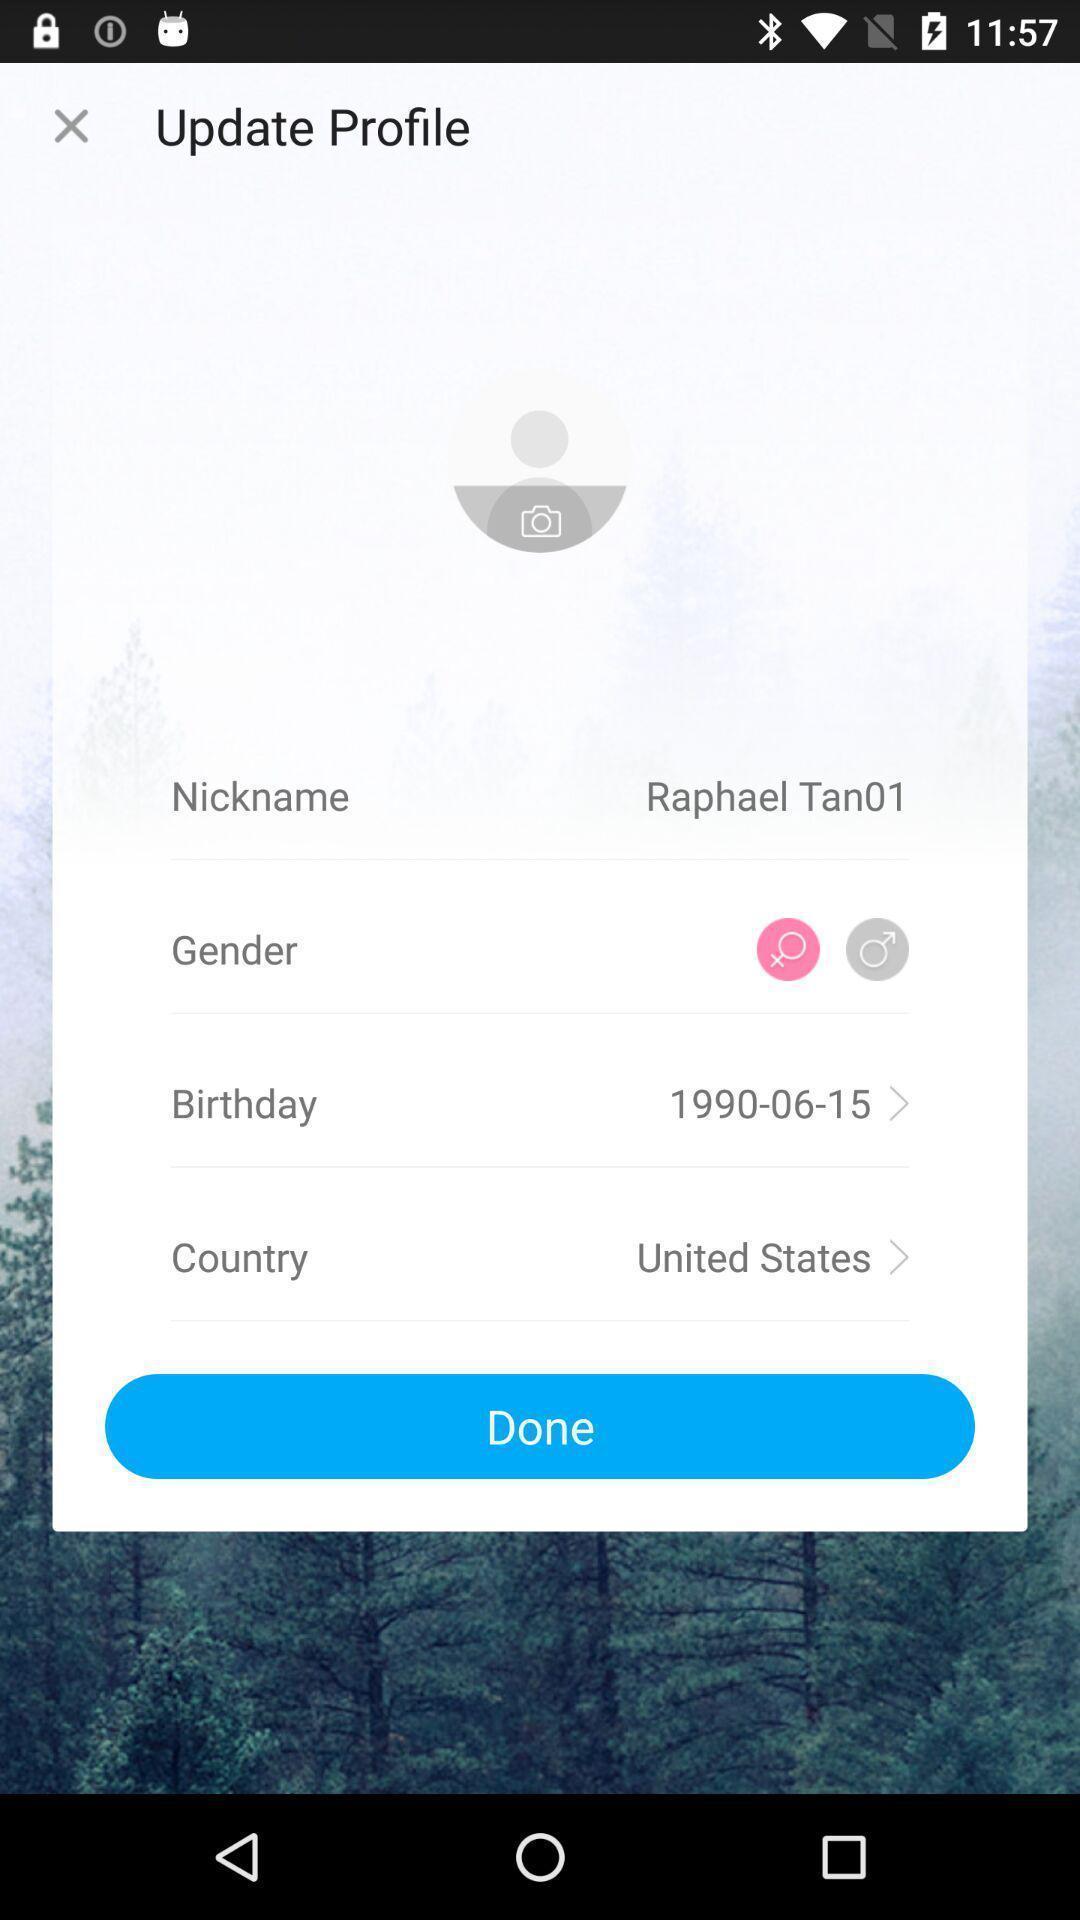Explain what's happening in this screen capture. Screen displaying a profile to update. 